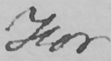Can you read and transcribe this handwriting? For 